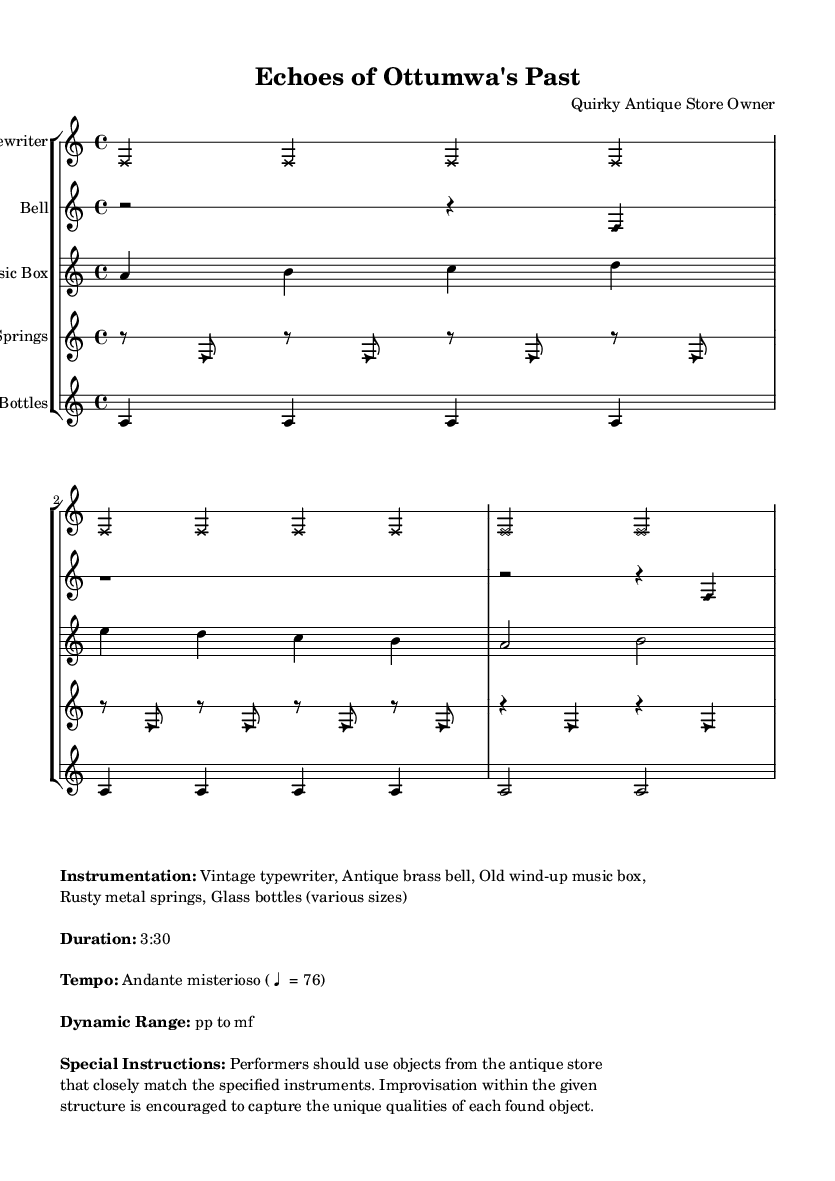What is the time signature of this piece? The time signature is indicated at the beginning of the piece as 4/4, which means there are four beats in a measure.
Answer: 4/4 What is the tempo marking for this composition? The tempo marking is provided in the markup section as Andante misterioso, which indicates a moderately slow tempo.
Answer: Andante misterioso How long is the duration of this piece? The duration is explicitly mentioned in the markup as 3:30, which denotes the total performance time.
Answer: 3:30 What is the dynamic range indicated in the piece? The dynamic range is found in the markup section, stating it goes from pp (pianissimo) to mf (mezzo-forte).
Answer: pp to mf Which found object represents the instrument named "Music Box"? The markup lists an "Old wind-up music box" as the object representing the instrument, directly associating it with the visual and performance elements.
Answer: Old wind-up music box Why is improvisation encouraged in this piece? The special instructions state that performers should use objects from the antique store that closely match the specified instruments, suggesting that improvisation is encouraged to highlight the unique characteristics of the found objects.
Answer: Unique characteristics of found objects 